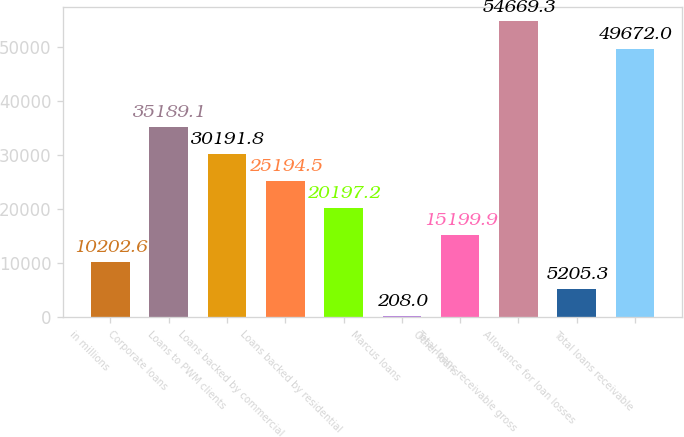Convert chart. <chart><loc_0><loc_0><loc_500><loc_500><bar_chart><fcel>in millions<fcel>Corporate loans<fcel>Loans to PWM clients<fcel>Loans backed by commercial<fcel>Loans backed by residential<fcel>Marcus loans<fcel>Other loans<fcel>Total loans receivable gross<fcel>Allowance for loan losses<fcel>Total loans receivable<nl><fcel>10202.6<fcel>35189.1<fcel>30191.8<fcel>25194.5<fcel>20197.2<fcel>208<fcel>15199.9<fcel>54669.3<fcel>5205.3<fcel>49672<nl></chart> 